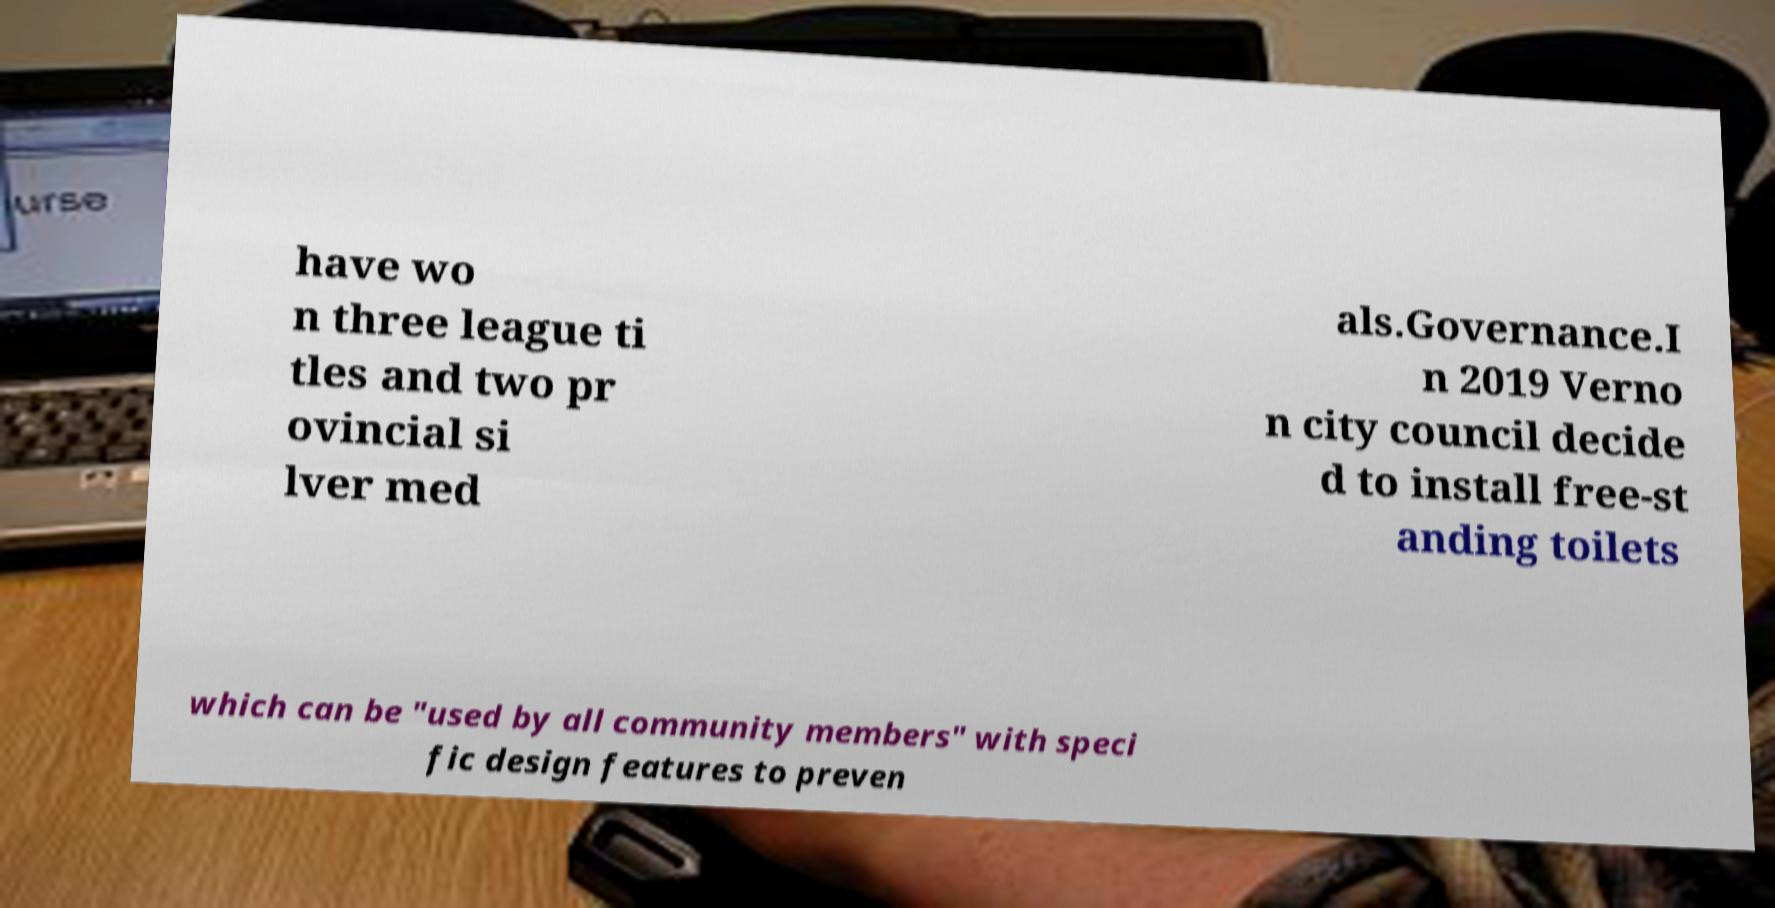Please identify and transcribe the text found in this image. have wo n three league ti tles and two pr ovincial si lver med als.Governance.I n 2019 Verno n city council decide d to install free-st anding toilets which can be "used by all community members" with speci fic design features to preven 